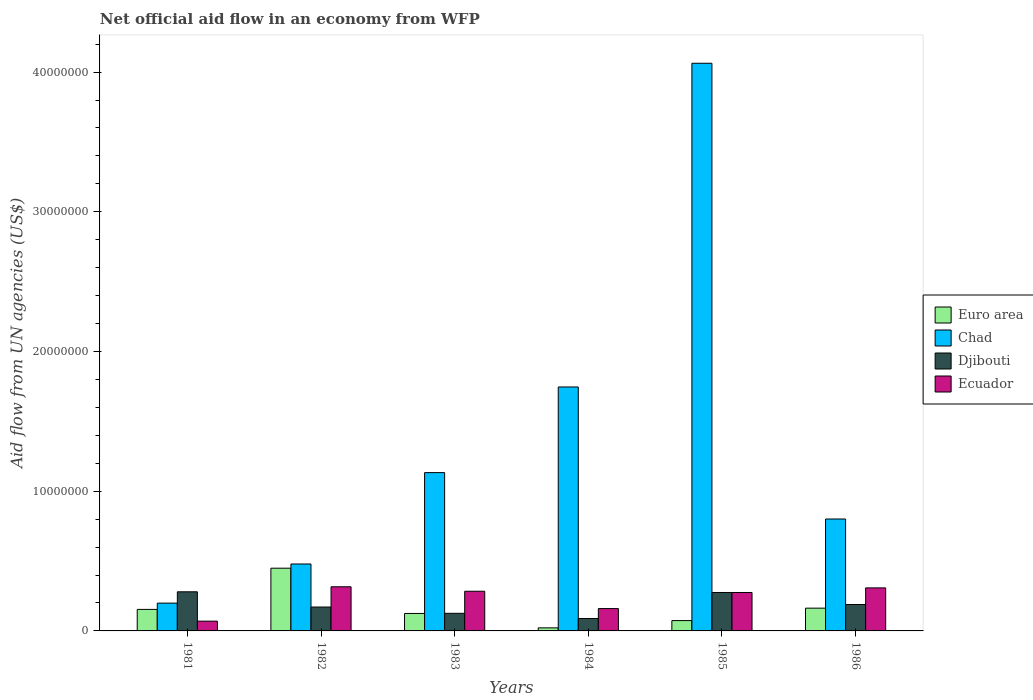Are the number of bars on each tick of the X-axis equal?
Keep it short and to the point. Yes. How many bars are there on the 3rd tick from the left?
Keep it short and to the point. 4. What is the label of the 6th group of bars from the left?
Ensure brevity in your answer.  1986. In how many cases, is the number of bars for a given year not equal to the number of legend labels?
Keep it short and to the point. 0. What is the net official aid flow in Ecuador in 1983?
Keep it short and to the point. 2.84e+06. Across all years, what is the maximum net official aid flow in Djibouti?
Ensure brevity in your answer.  2.80e+06. Across all years, what is the minimum net official aid flow in Chad?
Offer a terse response. 1.99e+06. In which year was the net official aid flow in Ecuador maximum?
Keep it short and to the point. 1982. What is the total net official aid flow in Euro area in the graph?
Your response must be concise. 9.87e+06. What is the difference between the net official aid flow in Djibouti in 1982 and that in 1983?
Your response must be concise. 4.50e+05. What is the difference between the net official aid flow in Djibouti in 1986 and the net official aid flow in Euro area in 1982?
Your response must be concise. -2.60e+06. What is the average net official aid flow in Ecuador per year?
Give a very brief answer. 2.36e+06. In the year 1981, what is the difference between the net official aid flow in Ecuador and net official aid flow in Chad?
Your answer should be compact. -1.29e+06. In how many years, is the net official aid flow in Djibouti greater than 34000000 US$?
Provide a short and direct response. 0. What is the ratio of the net official aid flow in Ecuador in 1981 to that in 1985?
Keep it short and to the point. 0.25. Is the net official aid flow in Ecuador in 1985 less than that in 1986?
Offer a very short reply. Yes. What is the difference between the highest and the second highest net official aid flow in Euro area?
Your response must be concise. 2.86e+06. What is the difference between the highest and the lowest net official aid flow in Chad?
Ensure brevity in your answer.  3.86e+07. In how many years, is the net official aid flow in Djibouti greater than the average net official aid flow in Djibouti taken over all years?
Provide a short and direct response. 3. Is the sum of the net official aid flow in Ecuador in 1985 and 1986 greater than the maximum net official aid flow in Djibouti across all years?
Keep it short and to the point. Yes. What does the 2nd bar from the left in 1981 represents?
Your answer should be very brief. Chad. What does the 4th bar from the right in 1985 represents?
Your response must be concise. Euro area. Is it the case that in every year, the sum of the net official aid flow in Djibouti and net official aid flow in Ecuador is greater than the net official aid flow in Euro area?
Give a very brief answer. Yes. What is the difference between two consecutive major ticks on the Y-axis?
Give a very brief answer. 1.00e+07. How many legend labels are there?
Provide a succinct answer. 4. How are the legend labels stacked?
Your answer should be very brief. Vertical. What is the title of the graph?
Your answer should be very brief. Net official aid flow in an economy from WFP. Does "Dominica" appear as one of the legend labels in the graph?
Your answer should be very brief. No. What is the label or title of the Y-axis?
Make the answer very short. Aid flow from UN agencies (US$). What is the Aid flow from UN agencies (US$) of Euro area in 1981?
Your answer should be very brief. 1.54e+06. What is the Aid flow from UN agencies (US$) in Chad in 1981?
Offer a terse response. 1.99e+06. What is the Aid flow from UN agencies (US$) of Djibouti in 1981?
Make the answer very short. 2.80e+06. What is the Aid flow from UN agencies (US$) in Ecuador in 1981?
Your response must be concise. 7.00e+05. What is the Aid flow from UN agencies (US$) of Euro area in 1982?
Ensure brevity in your answer.  4.49e+06. What is the Aid flow from UN agencies (US$) of Chad in 1982?
Give a very brief answer. 4.79e+06. What is the Aid flow from UN agencies (US$) in Djibouti in 1982?
Your response must be concise. 1.71e+06. What is the Aid flow from UN agencies (US$) in Ecuador in 1982?
Provide a succinct answer. 3.16e+06. What is the Aid flow from UN agencies (US$) of Euro area in 1983?
Offer a terse response. 1.25e+06. What is the Aid flow from UN agencies (US$) of Chad in 1983?
Make the answer very short. 1.13e+07. What is the Aid flow from UN agencies (US$) in Djibouti in 1983?
Provide a succinct answer. 1.26e+06. What is the Aid flow from UN agencies (US$) in Ecuador in 1983?
Give a very brief answer. 2.84e+06. What is the Aid flow from UN agencies (US$) in Euro area in 1984?
Offer a very short reply. 2.20e+05. What is the Aid flow from UN agencies (US$) in Chad in 1984?
Offer a terse response. 1.75e+07. What is the Aid flow from UN agencies (US$) of Djibouti in 1984?
Offer a very short reply. 8.90e+05. What is the Aid flow from UN agencies (US$) of Ecuador in 1984?
Ensure brevity in your answer.  1.60e+06. What is the Aid flow from UN agencies (US$) of Euro area in 1985?
Your answer should be very brief. 7.40e+05. What is the Aid flow from UN agencies (US$) in Chad in 1985?
Ensure brevity in your answer.  4.06e+07. What is the Aid flow from UN agencies (US$) of Djibouti in 1985?
Your response must be concise. 2.75e+06. What is the Aid flow from UN agencies (US$) of Ecuador in 1985?
Make the answer very short. 2.75e+06. What is the Aid flow from UN agencies (US$) of Euro area in 1986?
Ensure brevity in your answer.  1.63e+06. What is the Aid flow from UN agencies (US$) in Chad in 1986?
Your response must be concise. 8.01e+06. What is the Aid flow from UN agencies (US$) in Djibouti in 1986?
Your response must be concise. 1.89e+06. What is the Aid flow from UN agencies (US$) of Ecuador in 1986?
Offer a terse response. 3.08e+06. Across all years, what is the maximum Aid flow from UN agencies (US$) of Euro area?
Provide a succinct answer. 4.49e+06. Across all years, what is the maximum Aid flow from UN agencies (US$) in Chad?
Offer a very short reply. 4.06e+07. Across all years, what is the maximum Aid flow from UN agencies (US$) of Djibouti?
Make the answer very short. 2.80e+06. Across all years, what is the maximum Aid flow from UN agencies (US$) in Ecuador?
Give a very brief answer. 3.16e+06. Across all years, what is the minimum Aid flow from UN agencies (US$) of Euro area?
Offer a very short reply. 2.20e+05. Across all years, what is the minimum Aid flow from UN agencies (US$) of Chad?
Offer a terse response. 1.99e+06. Across all years, what is the minimum Aid flow from UN agencies (US$) of Djibouti?
Give a very brief answer. 8.90e+05. Across all years, what is the minimum Aid flow from UN agencies (US$) of Ecuador?
Offer a very short reply. 7.00e+05. What is the total Aid flow from UN agencies (US$) in Euro area in the graph?
Your answer should be very brief. 9.87e+06. What is the total Aid flow from UN agencies (US$) of Chad in the graph?
Your response must be concise. 8.42e+07. What is the total Aid flow from UN agencies (US$) of Djibouti in the graph?
Make the answer very short. 1.13e+07. What is the total Aid flow from UN agencies (US$) of Ecuador in the graph?
Make the answer very short. 1.41e+07. What is the difference between the Aid flow from UN agencies (US$) of Euro area in 1981 and that in 1982?
Provide a short and direct response. -2.95e+06. What is the difference between the Aid flow from UN agencies (US$) in Chad in 1981 and that in 1982?
Provide a succinct answer. -2.80e+06. What is the difference between the Aid flow from UN agencies (US$) of Djibouti in 1981 and that in 1982?
Your answer should be compact. 1.09e+06. What is the difference between the Aid flow from UN agencies (US$) of Ecuador in 1981 and that in 1982?
Your answer should be compact. -2.46e+06. What is the difference between the Aid flow from UN agencies (US$) of Euro area in 1981 and that in 1983?
Provide a short and direct response. 2.90e+05. What is the difference between the Aid flow from UN agencies (US$) in Chad in 1981 and that in 1983?
Ensure brevity in your answer.  -9.34e+06. What is the difference between the Aid flow from UN agencies (US$) of Djibouti in 1981 and that in 1983?
Give a very brief answer. 1.54e+06. What is the difference between the Aid flow from UN agencies (US$) of Ecuador in 1981 and that in 1983?
Your answer should be very brief. -2.14e+06. What is the difference between the Aid flow from UN agencies (US$) in Euro area in 1981 and that in 1984?
Your answer should be compact. 1.32e+06. What is the difference between the Aid flow from UN agencies (US$) in Chad in 1981 and that in 1984?
Offer a very short reply. -1.55e+07. What is the difference between the Aid flow from UN agencies (US$) in Djibouti in 1981 and that in 1984?
Your answer should be compact. 1.91e+06. What is the difference between the Aid flow from UN agencies (US$) of Ecuador in 1981 and that in 1984?
Provide a short and direct response. -9.00e+05. What is the difference between the Aid flow from UN agencies (US$) of Chad in 1981 and that in 1985?
Offer a very short reply. -3.86e+07. What is the difference between the Aid flow from UN agencies (US$) of Ecuador in 1981 and that in 1985?
Offer a very short reply. -2.05e+06. What is the difference between the Aid flow from UN agencies (US$) in Chad in 1981 and that in 1986?
Your response must be concise. -6.02e+06. What is the difference between the Aid flow from UN agencies (US$) of Djibouti in 1981 and that in 1986?
Offer a very short reply. 9.10e+05. What is the difference between the Aid flow from UN agencies (US$) of Ecuador in 1981 and that in 1986?
Offer a very short reply. -2.38e+06. What is the difference between the Aid flow from UN agencies (US$) in Euro area in 1982 and that in 1983?
Keep it short and to the point. 3.24e+06. What is the difference between the Aid flow from UN agencies (US$) of Chad in 1982 and that in 1983?
Make the answer very short. -6.54e+06. What is the difference between the Aid flow from UN agencies (US$) in Djibouti in 1982 and that in 1983?
Provide a short and direct response. 4.50e+05. What is the difference between the Aid flow from UN agencies (US$) in Euro area in 1982 and that in 1984?
Offer a terse response. 4.27e+06. What is the difference between the Aid flow from UN agencies (US$) of Chad in 1982 and that in 1984?
Your answer should be very brief. -1.27e+07. What is the difference between the Aid flow from UN agencies (US$) of Djibouti in 1982 and that in 1984?
Your answer should be very brief. 8.20e+05. What is the difference between the Aid flow from UN agencies (US$) in Ecuador in 1982 and that in 1984?
Provide a succinct answer. 1.56e+06. What is the difference between the Aid flow from UN agencies (US$) of Euro area in 1982 and that in 1985?
Offer a very short reply. 3.75e+06. What is the difference between the Aid flow from UN agencies (US$) of Chad in 1982 and that in 1985?
Keep it short and to the point. -3.58e+07. What is the difference between the Aid flow from UN agencies (US$) in Djibouti in 1982 and that in 1985?
Provide a succinct answer. -1.04e+06. What is the difference between the Aid flow from UN agencies (US$) of Ecuador in 1982 and that in 1985?
Provide a short and direct response. 4.10e+05. What is the difference between the Aid flow from UN agencies (US$) in Euro area in 1982 and that in 1986?
Give a very brief answer. 2.86e+06. What is the difference between the Aid flow from UN agencies (US$) of Chad in 1982 and that in 1986?
Provide a short and direct response. -3.22e+06. What is the difference between the Aid flow from UN agencies (US$) of Djibouti in 1982 and that in 1986?
Give a very brief answer. -1.80e+05. What is the difference between the Aid flow from UN agencies (US$) of Euro area in 1983 and that in 1984?
Offer a very short reply. 1.03e+06. What is the difference between the Aid flow from UN agencies (US$) in Chad in 1983 and that in 1984?
Offer a very short reply. -6.13e+06. What is the difference between the Aid flow from UN agencies (US$) in Ecuador in 1983 and that in 1984?
Your answer should be very brief. 1.24e+06. What is the difference between the Aid flow from UN agencies (US$) in Euro area in 1983 and that in 1985?
Your response must be concise. 5.10e+05. What is the difference between the Aid flow from UN agencies (US$) of Chad in 1983 and that in 1985?
Offer a very short reply. -2.93e+07. What is the difference between the Aid flow from UN agencies (US$) of Djibouti in 1983 and that in 1985?
Keep it short and to the point. -1.49e+06. What is the difference between the Aid flow from UN agencies (US$) of Ecuador in 1983 and that in 1985?
Provide a succinct answer. 9.00e+04. What is the difference between the Aid flow from UN agencies (US$) in Euro area in 1983 and that in 1986?
Your answer should be compact. -3.80e+05. What is the difference between the Aid flow from UN agencies (US$) in Chad in 1983 and that in 1986?
Ensure brevity in your answer.  3.32e+06. What is the difference between the Aid flow from UN agencies (US$) of Djibouti in 1983 and that in 1986?
Provide a short and direct response. -6.30e+05. What is the difference between the Aid flow from UN agencies (US$) of Euro area in 1984 and that in 1985?
Provide a succinct answer. -5.20e+05. What is the difference between the Aid flow from UN agencies (US$) in Chad in 1984 and that in 1985?
Give a very brief answer. -2.32e+07. What is the difference between the Aid flow from UN agencies (US$) in Djibouti in 1984 and that in 1985?
Provide a short and direct response. -1.86e+06. What is the difference between the Aid flow from UN agencies (US$) of Ecuador in 1984 and that in 1985?
Your answer should be very brief. -1.15e+06. What is the difference between the Aid flow from UN agencies (US$) of Euro area in 1984 and that in 1986?
Ensure brevity in your answer.  -1.41e+06. What is the difference between the Aid flow from UN agencies (US$) of Chad in 1984 and that in 1986?
Your answer should be compact. 9.45e+06. What is the difference between the Aid flow from UN agencies (US$) in Ecuador in 1984 and that in 1986?
Provide a short and direct response. -1.48e+06. What is the difference between the Aid flow from UN agencies (US$) of Euro area in 1985 and that in 1986?
Your answer should be very brief. -8.90e+05. What is the difference between the Aid flow from UN agencies (US$) of Chad in 1985 and that in 1986?
Make the answer very short. 3.26e+07. What is the difference between the Aid flow from UN agencies (US$) of Djibouti in 1985 and that in 1986?
Keep it short and to the point. 8.60e+05. What is the difference between the Aid flow from UN agencies (US$) of Ecuador in 1985 and that in 1986?
Your answer should be compact. -3.30e+05. What is the difference between the Aid flow from UN agencies (US$) of Euro area in 1981 and the Aid flow from UN agencies (US$) of Chad in 1982?
Offer a very short reply. -3.25e+06. What is the difference between the Aid flow from UN agencies (US$) in Euro area in 1981 and the Aid flow from UN agencies (US$) in Ecuador in 1982?
Ensure brevity in your answer.  -1.62e+06. What is the difference between the Aid flow from UN agencies (US$) in Chad in 1981 and the Aid flow from UN agencies (US$) in Djibouti in 1982?
Provide a succinct answer. 2.80e+05. What is the difference between the Aid flow from UN agencies (US$) in Chad in 1981 and the Aid flow from UN agencies (US$) in Ecuador in 1982?
Provide a short and direct response. -1.17e+06. What is the difference between the Aid flow from UN agencies (US$) in Djibouti in 1981 and the Aid flow from UN agencies (US$) in Ecuador in 1982?
Provide a short and direct response. -3.60e+05. What is the difference between the Aid flow from UN agencies (US$) in Euro area in 1981 and the Aid flow from UN agencies (US$) in Chad in 1983?
Ensure brevity in your answer.  -9.79e+06. What is the difference between the Aid flow from UN agencies (US$) in Euro area in 1981 and the Aid flow from UN agencies (US$) in Ecuador in 1983?
Keep it short and to the point. -1.30e+06. What is the difference between the Aid flow from UN agencies (US$) of Chad in 1981 and the Aid flow from UN agencies (US$) of Djibouti in 1983?
Your answer should be very brief. 7.30e+05. What is the difference between the Aid flow from UN agencies (US$) in Chad in 1981 and the Aid flow from UN agencies (US$) in Ecuador in 1983?
Make the answer very short. -8.50e+05. What is the difference between the Aid flow from UN agencies (US$) in Euro area in 1981 and the Aid flow from UN agencies (US$) in Chad in 1984?
Offer a very short reply. -1.59e+07. What is the difference between the Aid flow from UN agencies (US$) in Euro area in 1981 and the Aid flow from UN agencies (US$) in Djibouti in 1984?
Offer a terse response. 6.50e+05. What is the difference between the Aid flow from UN agencies (US$) of Chad in 1981 and the Aid flow from UN agencies (US$) of Djibouti in 1984?
Offer a very short reply. 1.10e+06. What is the difference between the Aid flow from UN agencies (US$) of Djibouti in 1981 and the Aid flow from UN agencies (US$) of Ecuador in 1984?
Your response must be concise. 1.20e+06. What is the difference between the Aid flow from UN agencies (US$) in Euro area in 1981 and the Aid flow from UN agencies (US$) in Chad in 1985?
Ensure brevity in your answer.  -3.91e+07. What is the difference between the Aid flow from UN agencies (US$) of Euro area in 1981 and the Aid flow from UN agencies (US$) of Djibouti in 1985?
Provide a succinct answer. -1.21e+06. What is the difference between the Aid flow from UN agencies (US$) in Euro area in 1981 and the Aid flow from UN agencies (US$) in Ecuador in 1985?
Provide a succinct answer. -1.21e+06. What is the difference between the Aid flow from UN agencies (US$) of Chad in 1981 and the Aid flow from UN agencies (US$) of Djibouti in 1985?
Keep it short and to the point. -7.60e+05. What is the difference between the Aid flow from UN agencies (US$) of Chad in 1981 and the Aid flow from UN agencies (US$) of Ecuador in 1985?
Make the answer very short. -7.60e+05. What is the difference between the Aid flow from UN agencies (US$) in Djibouti in 1981 and the Aid flow from UN agencies (US$) in Ecuador in 1985?
Your answer should be very brief. 5.00e+04. What is the difference between the Aid flow from UN agencies (US$) of Euro area in 1981 and the Aid flow from UN agencies (US$) of Chad in 1986?
Your response must be concise. -6.47e+06. What is the difference between the Aid flow from UN agencies (US$) in Euro area in 1981 and the Aid flow from UN agencies (US$) in Djibouti in 1986?
Offer a terse response. -3.50e+05. What is the difference between the Aid flow from UN agencies (US$) of Euro area in 1981 and the Aid flow from UN agencies (US$) of Ecuador in 1986?
Offer a terse response. -1.54e+06. What is the difference between the Aid flow from UN agencies (US$) in Chad in 1981 and the Aid flow from UN agencies (US$) in Djibouti in 1986?
Make the answer very short. 1.00e+05. What is the difference between the Aid flow from UN agencies (US$) of Chad in 1981 and the Aid flow from UN agencies (US$) of Ecuador in 1986?
Give a very brief answer. -1.09e+06. What is the difference between the Aid flow from UN agencies (US$) of Djibouti in 1981 and the Aid flow from UN agencies (US$) of Ecuador in 1986?
Ensure brevity in your answer.  -2.80e+05. What is the difference between the Aid flow from UN agencies (US$) in Euro area in 1982 and the Aid flow from UN agencies (US$) in Chad in 1983?
Provide a short and direct response. -6.84e+06. What is the difference between the Aid flow from UN agencies (US$) of Euro area in 1982 and the Aid flow from UN agencies (US$) of Djibouti in 1983?
Your answer should be very brief. 3.23e+06. What is the difference between the Aid flow from UN agencies (US$) of Euro area in 1982 and the Aid flow from UN agencies (US$) of Ecuador in 1983?
Offer a very short reply. 1.65e+06. What is the difference between the Aid flow from UN agencies (US$) of Chad in 1982 and the Aid flow from UN agencies (US$) of Djibouti in 1983?
Offer a very short reply. 3.53e+06. What is the difference between the Aid flow from UN agencies (US$) in Chad in 1982 and the Aid flow from UN agencies (US$) in Ecuador in 1983?
Provide a succinct answer. 1.95e+06. What is the difference between the Aid flow from UN agencies (US$) in Djibouti in 1982 and the Aid flow from UN agencies (US$) in Ecuador in 1983?
Your answer should be compact. -1.13e+06. What is the difference between the Aid flow from UN agencies (US$) of Euro area in 1982 and the Aid flow from UN agencies (US$) of Chad in 1984?
Provide a succinct answer. -1.30e+07. What is the difference between the Aid flow from UN agencies (US$) in Euro area in 1982 and the Aid flow from UN agencies (US$) in Djibouti in 1984?
Your response must be concise. 3.60e+06. What is the difference between the Aid flow from UN agencies (US$) in Euro area in 1982 and the Aid flow from UN agencies (US$) in Ecuador in 1984?
Offer a terse response. 2.89e+06. What is the difference between the Aid flow from UN agencies (US$) of Chad in 1982 and the Aid flow from UN agencies (US$) of Djibouti in 1984?
Your answer should be compact. 3.90e+06. What is the difference between the Aid flow from UN agencies (US$) of Chad in 1982 and the Aid flow from UN agencies (US$) of Ecuador in 1984?
Make the answer very short. 3.19e+06. What is the difference between the Aid flow from UN agencies (US$) of Euro area in 1982 and the Aid flow from UN agencies (US$) of Chad in 1985?
Give a very brief answer. -3.61e+07. What is the difference between the Aid flow from UN agencies (US$) of Euro area in 1982 and the Aid flow from UN agencies (US$) of Djibouti in 1985?
Your answer should be compact. 1.74e+06. What is the difference between the Aid flow from UN agencies (US$) in Euro area in 1982 and the Aid flow from UN agencies (US$) in Ecuador in 1985?
Your response must be concise. 1.74e+06. What is the difference between the Aid flow from UN agencies (US$) in Chad in 1982 and the Aid flow from UN agencies (US$) in Djibouti in 1985?
Offer a very short reply. 2.04e+06. What is the difference between the Aid flow from UN agencies (US$) of Chad in 1982 and the Aid flow from UN agencies (US$) of Ecuador in 1985?
Keep it short and to the point. 2.04e+06. What is the difference between the Aid flow from UN agencies (US$) in Djibouti in 1982 and the Aid flow from UN agencies (US$) in Ecuador in 1985?
Offer a terse response. -1.04e+06. What is the difference between the Aid flow from UN agencies (US$) of Euro area in 1982 and the Aid flow from UN agencies (US$) of Chad in 1986?
Provide a succinct answer. -3.52e+06. What is the difference between the Aid flow from UN agencies (US$) in Euro area in 1982 and the Aid flow from UN agencies (US$) in Djibouti in 1986?
Your answer should be compact. 2.60e+06. What is the difference between the Aid flow from UN agencies (US$) of Euro area in 1982 and the Aid flow from UN agencies (US$) of Ecuador in 1986?
Your response must be concise. 1.41e+06. What is the difference between the Aid flow from UN agencies (US$) in Chad in 1982 and the Aid flow from UN agencies (US$) in Djibouti in 1986?
Ensure brevity in your answer.  2.90e+06. What is the difference between the Aid flow from UN agencies (US$) in Chad in 1982 and the Aid flow from UN agencies (US$) in Ecuador in 1986?
Ensure brevity in your answer.  1.71e+06. What is the difference between the Aid flow from UN agencies (US$) of Djibouti in 1982 and the Aid flow from UN agencies (US$) of Ecuador in 1986?
Your answer should be compact. -1.37e+06. What is the difference between the Aid flow from UN agencies (US$) in Euro area in 1983 and the Aid flow from UN agencies (US$) in Chad in 1984?
Make the answer very short. -1.62e+07. What is the difference between the Aid flow from UN agencies (US$) in Euro area in 1983 and the Aid flow from UN agencies (US$) in Ecuador in 1984?
Your answer should be very brief. -3.50e+05. What is the difference between the Aid flow from UN agencies (US$) in Chad in 1983 and the Aid flow from UN agencies (US$) in Djibouti in 1984?
Provide a succinct answer. 1.04e+07. What is the difference between the Aid flow from UN agencies (US$) of Chad in 1983 and the Aid flow from UN agencies (US$) of Ecuador in 1984?
Offer a terse response. 9.73e+06. What is the difference between the Aid flow from UN agencies (US$) in Djibouti in 1983 and the Aid flow from UN agencies (US$) in Ecuador in 1984?
Give a very brief answer. -3.40e+05. What is the difference between the Aid flow from UN agencies (US$) of Euro area in 1983 and the Aid flow from UN agencies (US$) of Chad in 1985?
Your response must be concise. -3.94e+07. What is the difference between the Aid flow from UN agencies (US$) in Euro area in 1983 and the Aid flow from UN agencies (US$) in Djibouti in 1985?
Keep it short and to the point. -1.50e+06. What is the difference between the Aid flow from UN agencies (US$) of Euro area in 1983 and the Aid flow from UN agencies (US$) of Ecuador in 1985?
Your response must be concise. -1.50e+06. What is the difference between the Aid flow from UN agencies (US$) in Chad in 1983 and the Aid flow from UN agencies (US$) in Djibouti in 1985?
Your answer should be very brief. 8.58e+06. What is the difference between the Aid flow from UN agencies (US$) in Chad in 1983 and the Aid flow from UN agencies (US$) in Ecuador in 1985?
Provide a succinct answer. 8.58e+06. What is the difference between the Aid flow from UN agencies (US$) of Djibouti in 1983 and the Aid flow from UN agencies (US$) of Ecuador in 1985?
Your answer should be very brief. -1.49e+06. What is the difference between the Aid flow from UN agencies (US$) in Euro area in 1983 and the Aid flow from UN agencies (US$) in Chad in 1986?
Make the answer very short. -6.76e+06. What is the difference between the Aid flow from UN agencies (US$) in Euro area in 1983 and the Aid flow from UN agencies (US$) in Djibouti in 1986?
Provide a short and direct response. -6.40e+05. What is the difference between the Aid flow from UN agencies (US$) of Euro area in 1983 and the Aid flow from UN agencies (US$) of Ecuador in 1986?
Make the answer very short. -1.83e+06. What is the difference between the Aid flow from UN agencies (US$) of Chad in 1983 and the Aid flow from UN agencies (US$) of Djibouti in 1986?
Provide a succinct answer. 9.44e+06. What is the difference between the Aid flow from UN agencies (US$) of Chad in 1983 and the Aid flow from UN agencies (US$) of Ecuador in 1986?
Keep it short and to the point. 8.25e+06. What is the difference between the Aid flow from UN agencies (US$) of Djibouti in 1983 and the Aid flow from UN agencies (US$) of Ecuador in 1986?
Offer a terse response. -1.82e+06. What is the difference between the Aid flow from UN agencies (US$) of Euro area in 1984 and the Aid flow from UN agencies (US$) of Chad in 1985?
Your answer should be compact. -4.04e+07. What is the difference between the Aid flow from UN agencies (US$) in Euro area in 1984 and the Aid flow from UN agencies (US$) in Djibouti in 1985?
Your response must be concise. -2.53e+06. What is the difference between the Aid flow from UN agencies (US$) of Euro area in 1984 and the Aid flow from UN agencies (US$) of Ecuador in 1985?
Provide a succinct answer. -2.53e+06. What is the difference between the Aid flow from UN agencies (US$) in Chad in 1984 and the Aid flow from UN agencies (US$) in Djibouti in 1985?
Give a very brief answer. 1.47e+07. What is the difference between the Aid flow from UN agencies (US$) in Chad in 1984 and the Aid flow from UN agencies (US$) in Ecuador in 1985?
Offer a terse response. 1.47e+07. What is the difference between the Aid flow from UN agencies (US$) of Djibouti in 1984 and the Aid flow from UN agencies (US$) of Ecuador in 1985?
Keep it short and to the point. -1.86e+06. What is the difference between the Aid flow from UN agencies (US$) of Euro area in 1984 and the Aid flow from UN agencies (US$) of Chad in 1986?
Your response must be concise. -7.79e+06. What is the difference between the Aid flow from UN agencies (US$) of Euro area in 1984 and the Aid flow from UN agencies (US$) of Djibouti in 1986?
Keep it short and to the point. -1.67e+06. What is the difference between the Aid flow from UN agencies (US$) of Euro area in 1984 and the Aid flow from UN agencies (US$) of Ecuador in 1986?
Give a very brief answer. -2.86e+06. What is the difference between the Aid flow from UN agencies (US$) in Chad in 1984 and the Aid flow from UN agencies (US$) in Djibouti in 1986?
Give a very brief answer. 1.56e+07. What is the difference between the Aid flow from UN agencies (US$) of Chad in 1984 and the Aid flow from UN agencies (US$) of Ecuador in 1986?
Provide a succinct answer. 1.44e+07. What is the difference between the Aid flow from UN agencies (US$) of Djibouti in 1984 and the Aid flow from UN agencies (US$) of Ecuador in 1986?
Make the answer very short. -2.19e+06. What is the difference between the Aid flow from UN agencies (US$) of Euro area in 1985 and the Aid flow from UN agencies (US$) of Chad in 1986?
Your answer should be very brief. -7.27e+06. What is the difference between the Aid flow from UN agencies (US$) in Euro area in 1985 and the Aid flow from UN agencies (US$) in Djibouti in 1986?
Your answer should be compact. -1.15e+06. What is the difference between the Aid flow from UN agencies (US$) of Euro area in 1985 and the Aid flow from UN agencies (US$) of Ecuador in 1986?
Ensure brevity in your answer.  -2.34e+06. What is the difference between the Aid flow from UN agencies (US$) in Chad in 1985 and the Aid flow from UN agencies (US$) in Djibouti in 1986?
Your answer should be compact. 3.87e+07. What is the difference between the Aid flow from UN agencies (US$) of Chad in 1985 and the Aid flow from UN agencies (US$) of Ecuador in 1986?
Provide a short and direct response. 3.76e+07. What is the difference between the Aid flow from UN agencies (US$) of Djibouti in 1985 and the Aid flow from UN agencies (US$) of Ecuador in 1986?
Offer a very short reply. -3.30e+05. What is the average Aid flow from UN agencies (US$) in Euro area per year?
Provide a short and direct response. 1.64e+06. What is the average Aid flow from UN agencies (US$) of Chad per year?
Ensure brevity in your answer.  1.40e+07. What is the average Aid flow from UN agencies (US$) of Djibouti per year?
Make the answer very short. 1.88e+06. What is the average Aid flow from UN agencies (US$) of Ecuador per year?
Your response must be concise. 2.36e+06. In the year 1981, what is the difference between the Aid flow from UN agencies (US$) in Euro area and Aid flow from UN agencies (US$) in Chad?
Offer a terse response. -4.50e+05. In the year 1981, what is the difference between the Aid flow from UN agencies (US$) in Euro area and Aid flow from UN agencies (US$) in Djibouti?
Offer a terse response. -1.26e+06. In the year 1981, what is the difference between the Aid flow from UN agencies (US$) of Euro area and Aid flow from UN agencies (US$) of Ecuador?
Make the answer very short. 8.40e+05. In the year 1981, what is the difference between the Aid flow from UN agencies (US$) of Chad and Aid flow from UN agencies (US$) of Djibouti?
Provide a succinct answer. -8.10e+05. In the year 1981, what is the difference between the Aid flow from UN agencies (US$) of Chad and Aid flow from UN agencies (US$) of Ecuador?
Keep it short and to the point. 1.29e+06. In the year 1981, what is the difference between the Aid flow from UN agencies (US$) in Djibouti and Aid flow from UN agencies (US$) in Ecuador?
Your response must be concise. 2.10e+06. In the year 1982, what is the difference between the Aid flow from UN agencies (US$) of Euro area and Aid flow from UN agencies (US$) of Chad?
Offer a terse response. -3.00e+05. In the year 1982, what is the difference between the Aid flow from UN agencies (US$) of Euro area and Aid flow from UN agencies (US$) of Djibouti?
Your answer should be very brief. 2.78e+06. In the year 1982, what is the difference between the Aid flow from UN agencies (US$) of Euro area and Aid flow from UN agencies (US$) of Ecuador?
Ensure brevity in your answer.  1.33e+06. In the year 1982, what is the difference between the Aid flow from UN agencies (US$) in Chad and Aid flow from UN agencies (US$) in Djibouti?
Offer a very short reply. 3.08e+06. In the year 1982, what is the difference between the Aid flow from UN agencies (US$) of Chad and Aid flow from UN agencies (US$) of Ecuador?
Make the answer very short. 1.63e+06. In the year 1982, what is the difference between the Aid flow from UN agencies (US$) in Djibouti and Aid flow from UN agencies (US$) in Ecuador?
Keep it short and to the point. -1.45e+06. In the year 1983, what is the difference between the Aid flow from UN agencies (US$) in Euro area and Aid flow from UN agencies (US$) in Chad?
Make the answer very short. -1.01e+07. In the year 1983, what is the difference between the Aid flow from UN agencies (US$) in Euro area and Aid flow from UN agencies (US$) in Djibouti?
Your answer should be very brief. -10000. In the year 1983, what is the difference between the Aid flow from UN agencies (US$) in Euro area and Aid flow from UN agencies (US$) in Ecuador?
Keep it short and to the point. -1.59e+06. In the year 1983, what is the difference between the Aid flow from UN agencies (US$) in Chad and Aid flow from UN agencies (US$) in Djibouti?
Provide a short and direct response. 1.01e+07. In the year 1983, what is the difference between the Aid flow from UN agencies (US$) in Chad and Aid flow from UN agencies (US$) in Ecuador?
Offer a terse response. 8.49e+06. In the year 1983, what is the difference between the Aid flow from UN agencies (US$) in Djibouti and Aid flow from UN agencies (US$) in Ecuador?
Provide a short and direct response. -1.58e+06. In the year 1984, what is the difference between the Aid flow from UN agencies (US$) of Euro area and Aid flow from UN agencies (US$) of Chad?
Offer a terse response. -1.72e+07. In the year 1984, what is the difference between the Aid flow from UN agencies (US$) of Euro area and Aid flow from UN agencies (US$) of Djibouti?
Your answer should be compact. -6.70e+05. In the year 1984, what is the difference between the Aid flow from UN agencies (US$) in Euro area and Aid flow from UN agencies (US$) in Ecuador?
Provide a succinct answer. -1.38e+06. In the year 1984, what is the difference between the Aid flow from UN agencies (US$) in Chad and Aid flow from UN agencies (US$) in Djibouti?
Offer a very short reply. 1.66e+07. In the year 1984, what is the difference between the Aid flow from UN agencies (US$) of Chad and Aid flow from UN agencies (US$) of Ecuador?
Provide a succinct answer. 1.59e+07. In the year 1984, what is the difference between the Aid flow from UN agencies (US$) in Djibouti and Aid flow from UN agencies (US$) in Ecuador?
Make the answer very short. -7.10e+05. In the year 1985, what is the difference between the Aid flow from UN agencies (US$) of Euro area and Aid flow from UN agencies (US$) of Chad?
Give a very brief answer. -3.99e+07. In the year 1985, what is the difference between the Aid flow from UN agencies (US$) in Euro area and Aid flow from UN agencies (US$) in Djibouti?
Your answer should be very brief. -2.01e+06. In the year 1985, what is the difference between the Aid flow from UN agencies (US$) of Euro area and Aid flow from UN agencies (US$) of Ecuador?
Provide a short and direct response. -2.01e+06. In the year 1985, what is the difference between the Aid flow from UN agencies (US$) in Chad and Aid flow from UN agencies (US$) in Djibouti?
Your answer should be very brief. 3.79e+07. In the year 1985, what is the difference between the Aid flow from UN agencies (US$) of Chad and Aid flow from UN agencies (US$) of Ecuador?
Your answer should be very brief. 3.79e+07. In the year 1986, what is the difference between the Aid flow from UN agencies (US$) in Euro area and Aid flow from UN agencies (US$) in Chad?
Give a very brief answer. -6.38e+06. In the year 1986, what is the difference between the Aid flow from UN agencies (US$) in Euro area and Aid flow from UN agencies (US$) in Djibouti?
Your answer should be compact. -2.60e+05. In the year 1986, what is the difference between the Aid flow from UN agencies (US$) of Euro area and Aid flow from UN agencies (US$) of Ecuador?
Offer a very short reply. -1.45e+06. In the year 1986, what is the difference between the Aid flow from UN agencies (US$) in Chad and Aid flow from UN agencies (US$) in Djibouti?
Give a very brief answer. 6.12e+06. In the year 1986, what is the difference between the Aid flow from UN agencies (US$) of Chad and Aid flow from UN agencies (US$) of Ecuador?
Make the answer very short. 4.93e+06. In the year 1986, what is the difference between the Aid flow from UN agencies (US$) in Djibouti and Aid flow from UN agencies (US$) in Ecuador?
Keep it short and to the point. -1.19e+06. What is the ratio of the Aid flow from UN agencies (US$) of Euro area in 1981 to that in 1982?
Offer a terse response. 0.34. What is the ratio of the Aid flow from UN agencies (US$) in Chad in 1981 to that in 1982?
Offer a terse response. 0.42. What is the ratio of the Aid flow from UN agencies (US$) of Djibouti in 1981 to that in 1982?
Your answer should be very brief. 1.64. What is the ratio of the Aid flow from UN agencies (US$) of Ecuador in 1981 to that in 1982?
Offer a terse response. 0.22. What is the ratio of the Aid flow from UN agencies (US$) in Euro area in 1981 to that in 1983?
Provide a succinct answer. 1.23. What is the ratio of the Aid flow from UN agencies (US$) in Chad in 1981 to that in 1983?
Your answer should be compact. 0.18. What is the ratio of the Aid flow from UN agencies (US$) of Djibouti in 1981 to that in 1983?
Make the answer very short. 2.22. What is the ratio of the Aid flow from UN agencies (US$) in Ecuador in 1981 to that in 1983?
Your answer should be very brief. 0.25. What is the ratio of the Aid flow from UN agencies (US$) of Euro area in 1981 to that in 1984?
Your answer should be very brief. 7. What is the ratio of the Aid flow from UN agencies (US$) of Chad in 1981 to that in 1984?
Give a very brief answer. 0.11. What is the ratio of the Aid flow from UN agencies (US$) of Djibouti in 1981 to that in 1984?
Provide a short and direct response. 3.15. What is the ratio of the Aid flow from UN agencies (US$) in Ecuador in 1981 to that in 1984?
Provide a succinct answer. 0.44. What is the ratio of the Aid flow from UN agencies (US$) in Euro area in 1981 to that in 1985?
Provide a short and direct response. 2.08. What is the ratio of the Aid flow from UN agencies (US$) in Chad in 1981 to that in 1985?
Keep it short and to the point. 0.05. What is the ratio of the Aid flow from UN agencies (US$) of Djibouti in 1981 to that in 1985?
Your answer should be compact. 1.02. What is the ratio of the Aid flow from UN agencies (US$) of Ecuador in 1981 to that in 1985?
Ensure brevity in your answer.  0.25. What is the ratio of the Aid flow from UN agencies (US$) in Euro area in 1981 to that in 1986?
Make the answer very short. 0.94. What is the ratio of the Aid flow from UN agencies (US$) in Chad in 1981 to that in 1986?
Keep it short and to the point. 0.25. What is the ratio of the Aid flow from UN agencies (US$) of Djibouti in 1981 to that in 1986?
Ensure brevity in your answer.  1.48. What is the ratio of the Aid flow from UN agencies (US$) in Ecuador in 1981 to that in 1986?
Provide a short and direct response. 0.23. What is the ratio of the Aid flow from UN agencies (US$) in Euro area in 1982 to that in 1983?
Ensure brevity in your answer.  3.59. What is the ratio of the Aid flow from UN agencies (US$) in Chad in 1982 to that in 1983?
Offer a terse response. 0.42. What is the ratio of the Aid flow from UN agencies (US$) of Djibouti in 1982 to that in 1983?
Provide a succinct answer. 1.36. What is the ratio of the Aid flow from UN agencies (US$) of Ecuador in 1982 to that in 1983?
Ensure brevity in your answer.  1.11. What is the ratio of the Aid flow from UN agencies (US$) in Euro area in 1982 to that in 1984?
Your answer should be very brief. 20.41. What is the ratio of the Aid flow from UN agencies (US$) in Chad in 1982 to that in 1984?
Your answer should be compact. 0.27. What is the ratio of the Aid flow from UN agencies (US$) in Djibouti in 1982 to that in 1984?
Provide a short and direct response. 1.92. What is the ratio of the Aid flow from UN agencies (US$) in Ecuador in 1982 to that in 1984?
Your answer should be very brief. 1.98. What is the ratio of the Aid flow from UN agencies (US$) in Euro area in 1982 to that in 1985?
Your answer should be very brief. 6.07. What is the ratio of the Aid flow from UN agencies (US$) of Chad in 1982 to that in 1985?
Make the answer very short. 0.12. What is the ratio of the Aid flow from UN agencies (US$) in Djibouti in 1982 to that in 1985?
Your response must be concise. 0.62. What is the ratio of the Aid flow from UN agencies (US$) in Ecuador in 1982 to that in 1985?
Give a very brief answer. 1.15. What is the ratio of the Aid flow from UN agencies (US$) of Euro area in 1982 to that in 1986?
Give a very brief answer. 2.75. What is the ratio of the Aid flow from UN agencies (US$) of Chad in 1982 to that in 1986?
Your answer should be very brief. 0.6. What is the ratio of the Aid flow from UN agencies (US$) of Djibouti in 1982 to that in 1986?
Your answer should be compact. 0.9. What is the ratio of the Aid flow from UN agencies (US$) of Ecuador in 1982 to that in 1986?
Your answer should be very brief. 1.03. What is the ratio of the Aid flow from UN agencies (US$) in Euro area in 1983 to that in 1984?
Ensure brevity in your answer.  5.68. What is the ratio of the Aid flow from UN agencies (US$) of Chad in 1983 to that in 1984?
Offer a terse response. 0.65. What is the ratio of the Aid flow from UN agencies (US$) in Djibouti in 1983 to that in 1984?
Your answer should be compact. 1.42. What is the ratio of the Aid flow from UN agencies (US$) in Ecuador in 1983 to that in 1984?
Provide a short and direct response. 1.77. What is the ratio of the Aid flow from UN agencies (US$) in Euro area in 1983 to that in 1985?
Keep it short and to the point. 1.69. What is the ratio of the Aid flow from UN agencies (US$) in Chad in 1983 to that in 1985?
Offer a very short reply. 0.28. What is the ratio of the Aid flow from UN agencies (US$) in Djibouti in 1983 to that in 1985?
Provide a succinct answer. 0.46. What is the ratio of the Aid flow from UN agencies (US$) of Ecuador in 1983 to that in 1985?
Ensure brevity in your answer.  1.03. What is the ratio of the Aid flow from UN agencies (US$) in Euro area in 1983 to that in 1986?
Provide a short and direct response. 0.77. What is the ratio of the Aid flow from UN agencies (US$) of Chad in 1983 to that in 1986?
Your answer should be compact. 1.41. What is the ratio of the Aid flow from UN agencies (US$) in Ecuador in 1983 to that in 1986?
Provide a short and direct response. 0.92. What is the ratio of the Aid flow from UN agencies (US$) of Euro area in 1984 to that in 1985?
Your answer should be very brief. 0.3. What is the ratio of the Aid flow from UN agencies (US$) in Chad in 1984 to that in 1985?
Your answer should be compact. 0.43. What is the ratio of the Aid flow from UN agencies (US$) of Djibouti in 1984 to that in 1985?
Give a very brief answer. 0.32. What is the ratio of the Aid flow from UN agencies (US$) in Ecuador in 1984 to that in 1985?
Give a very brief answer. 0.58. What is the ratio of the Aid flow from UN agencies (US$) in Euro area in 1984 to that in 1986?
Offer a very short reply. 0.14. What is the ratio of the Aid flow from UN agencies (US$) in Chad in 1984 to that in 1986?
Ensure brevity in your answer.  2.18. What is the ratio of the Aid flow from UN agencies (US$) of Djibouti in 1984 to that in 1986?
Offer a terse response. 0.47. What is the ratio of the Aid flow from UN agencies (US$) in Ecuador in 1984 to that in 1986?
Offer a very short reply. 0.52. What is the ratio of the Aid flow from UN agencies (US$) of Euro area in 1985 to that in 1986?
Keep it short and to the point. 0.45. What is the ratio of the Aid flow from UN agencies (US$) of Chad in 1985 to that in 1986?
Make the answer very short. 5.07. What is the ratio of the Aid flow from UN agencies (US$) of Djibouti in 1985 to that in 1986?
Make the answer very short. 1.46. What is the ratio of the Aid flow from UN agencies (US$) of Ecuador in 1985 to that in 1986?
Give a very brief answer. 0.89. What is the difference between the highest and the second highest Aid flow from UN agencies (US$) of Euro area?
Make the answer very short. 2.86e+06. What is the difference between the highest and the second highest Aid flow from UN agencies (US$) of Chad?
Make the answer very short. 2.32e+07. What is the difference between the highest and the second highest Aid flow from UN agencies (US$) of Djibouti?
Ensure brevity in your answer.  5.00e+04. What is the difference between the highest and the lowest Aid flow from UN agencies (US$) in Euro area?
Your answer should be compact. 4.27e+06. What is the difference between the highest and the lowest Aid flow from UN agencies (US$) of Chad?
Ensure brevity in your answer.  3.86e+07. What is the difference between the highest and the lowest Aid flow from UN agencies (US$) of Djibouti?
Provide a succinct answer. 1.91e+06. What is the difference between the highest and the lowest Aid flow from UN agencies (US$) of Ecuador?
Your response must be concise. 2.46e+06. 